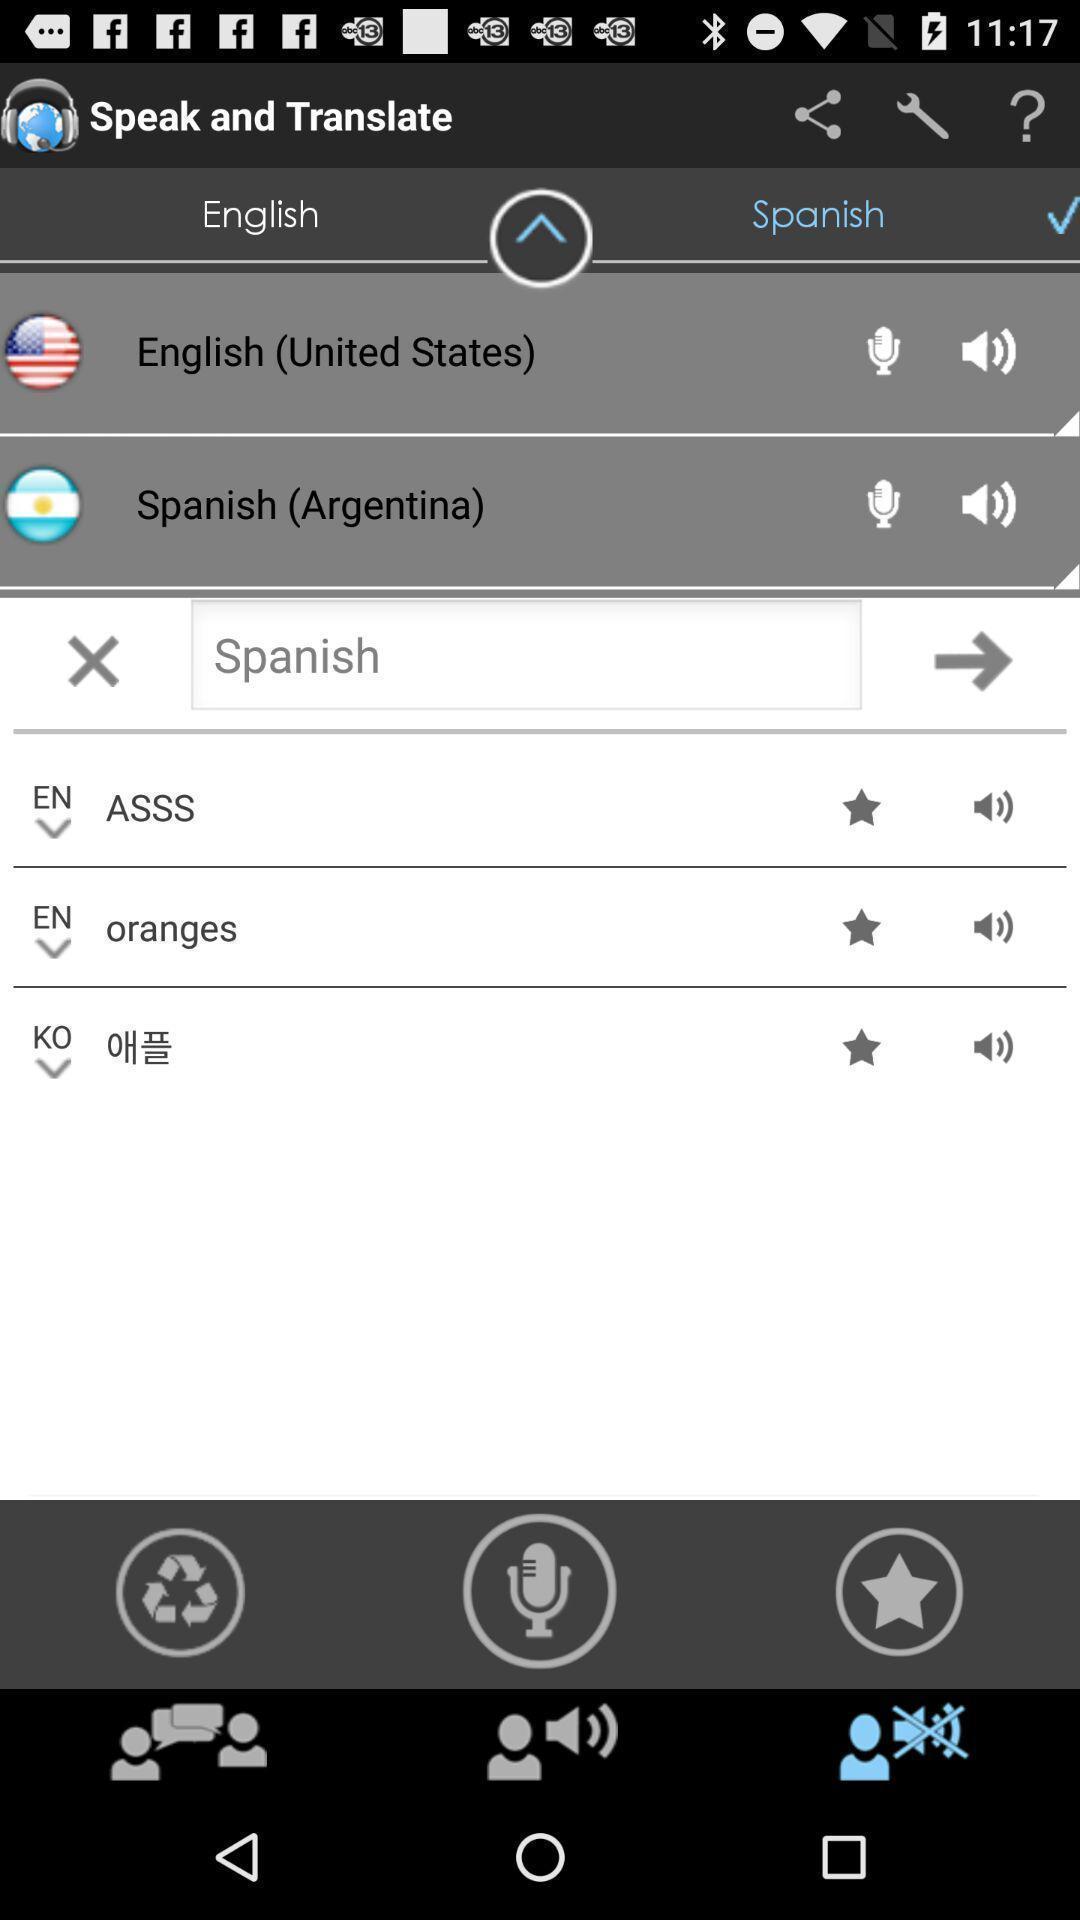Give me a summary of this screen capture. Page showing different options in a language translation app. 